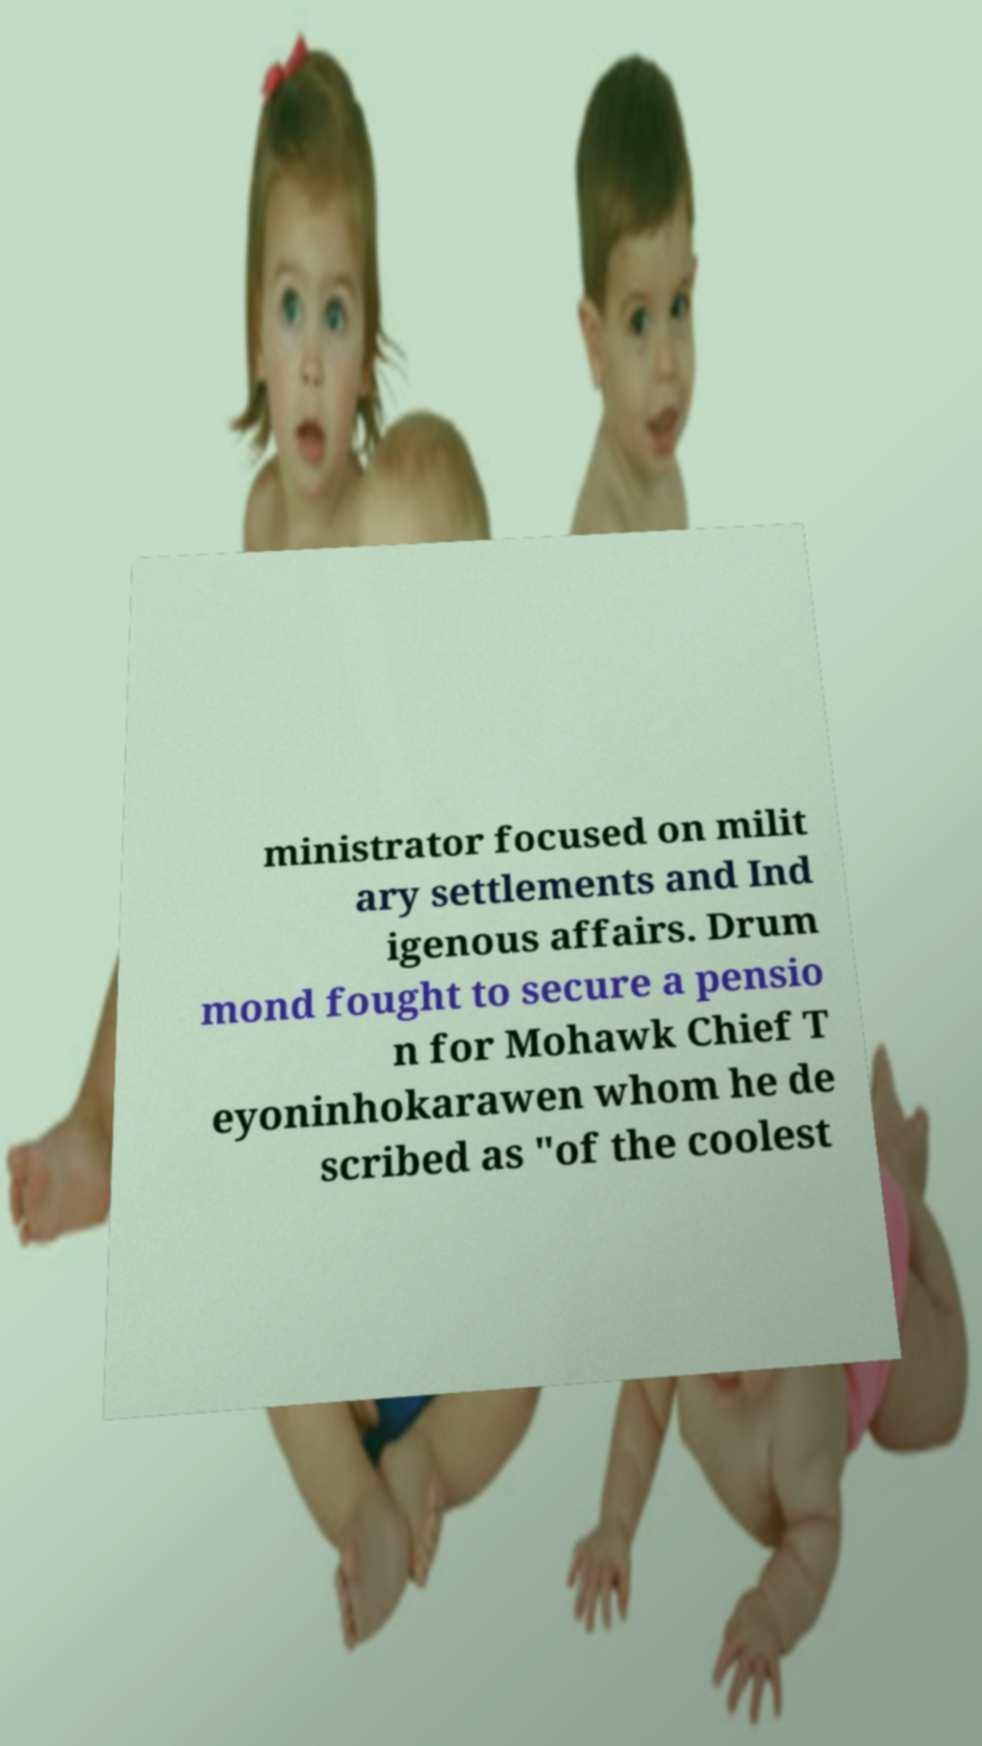Please read and relay the text visible in this image. What does it say? ministrator focused on milit ary settlements and Ind igenous affairs. Drum mond fought to secure a pensio n for Mohawk Chief T eyoninhokarawen whom he de scribed as "of the coolest 